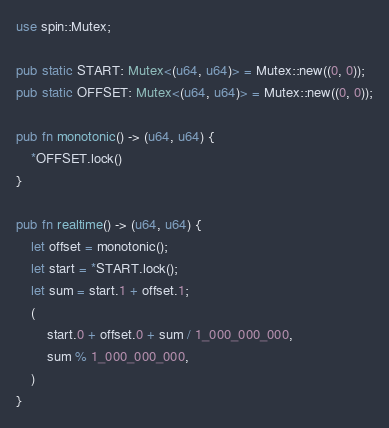Convert code to text. <code><loc_0><loc_0><loc_500><loc_500><_Rust_>use spin::Mutex;

pub static START: Mutex<(u64, u64)> = Mutex::new((0, 0));
pub static OFFSET: Mutex<(u64, u64)> = Mutex::new((0, 0));

pub fn monotonic() -> (u64, u64) {
    *OFFSET.lock()
}

pub fn realtime() -> (u64, u64) {
    let offset = monotonic();
    let start = *START.lock();
    let sum = start.1 + offset.1;
    (
        start.0 + offset.0 + sum / 1_000_000_000,
        sum % 1_000_000_000,
    )
}










</code> 